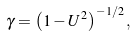<formula> <loc_0><loc_0><loc_500><loc_500>\gamma = \left ( 1 - U ^ { 2 } \right ) ^ { - 1 / 2 } ,</formula> 